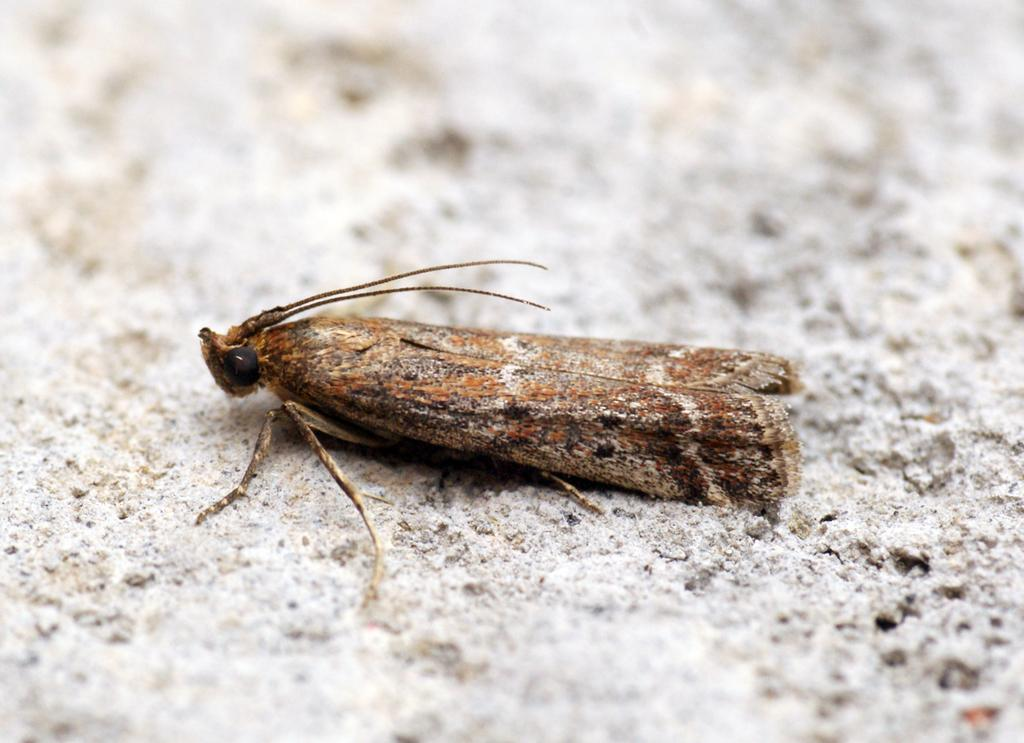What type of creature can be seen in the image? There is an insect in the image. Can you describe the background of the image? The background of the image is blurred. What type of business is being conducted in the image? There is no indication of any business activity in the image, as it features an insect and a blurred background. Can you see a basketball in the image? There is no basketball present in the image. 